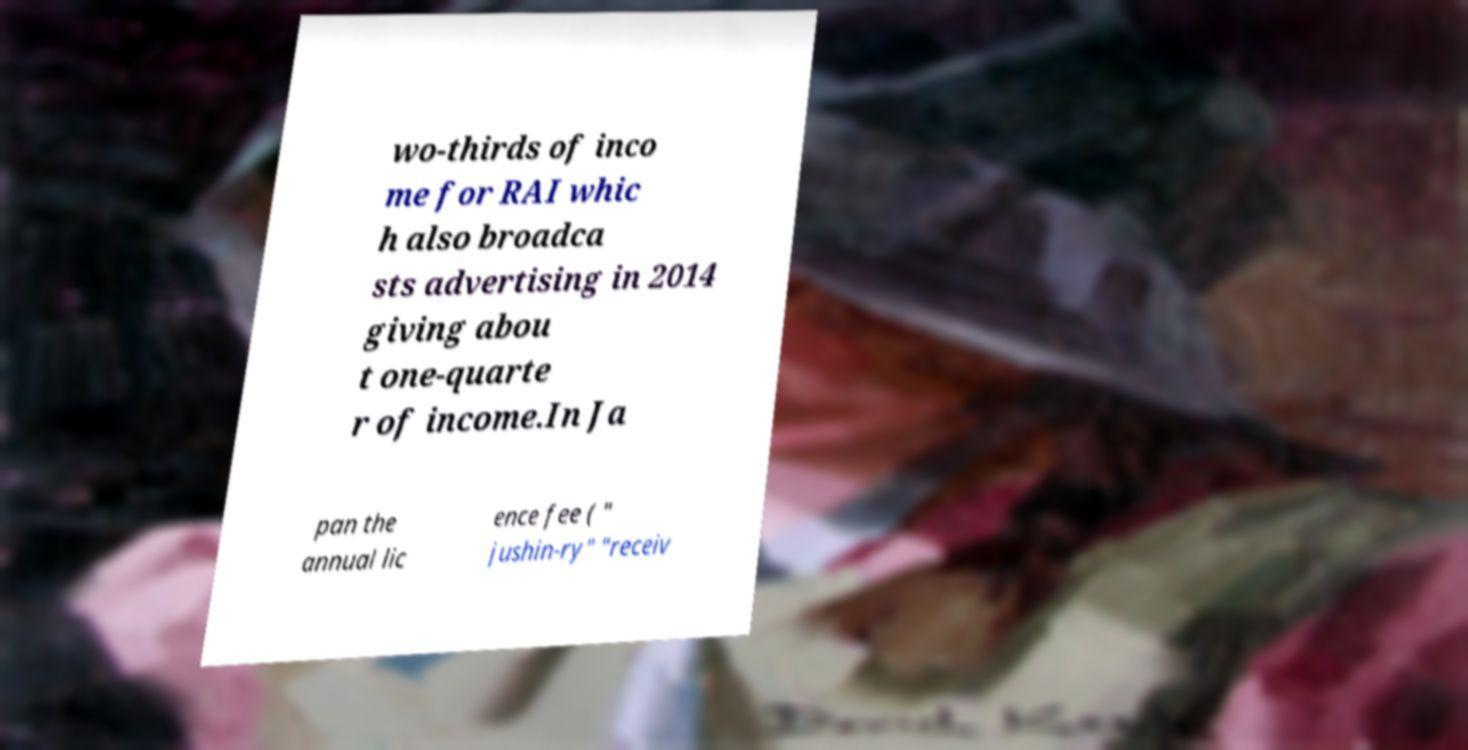Could you assist in decoding the text presented in this image and type it out clearly? wo-thirds of inco me for RAI whic h also broadca sts advertising in 2014 giving abou t one-quarte r of income.In Ja pan the annual lic ence fee ( " jushin-ry" "receiv 